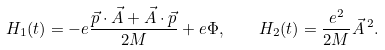Convert formula to latex. <formula><loc_0><loc_0><loc_500><loc_500>H _ { 1 } ( t ) = - e \frac { \vec { p } \cdot \vec { A } + \vec { A } \cdot { \vec { p } } } { 2 M } + e \Phi , \quad H _ { 2 } ( t ) = \frac { e ^ { 2 } } { 2 M } \vec { A } \, ^ { 2 } .</formula> 